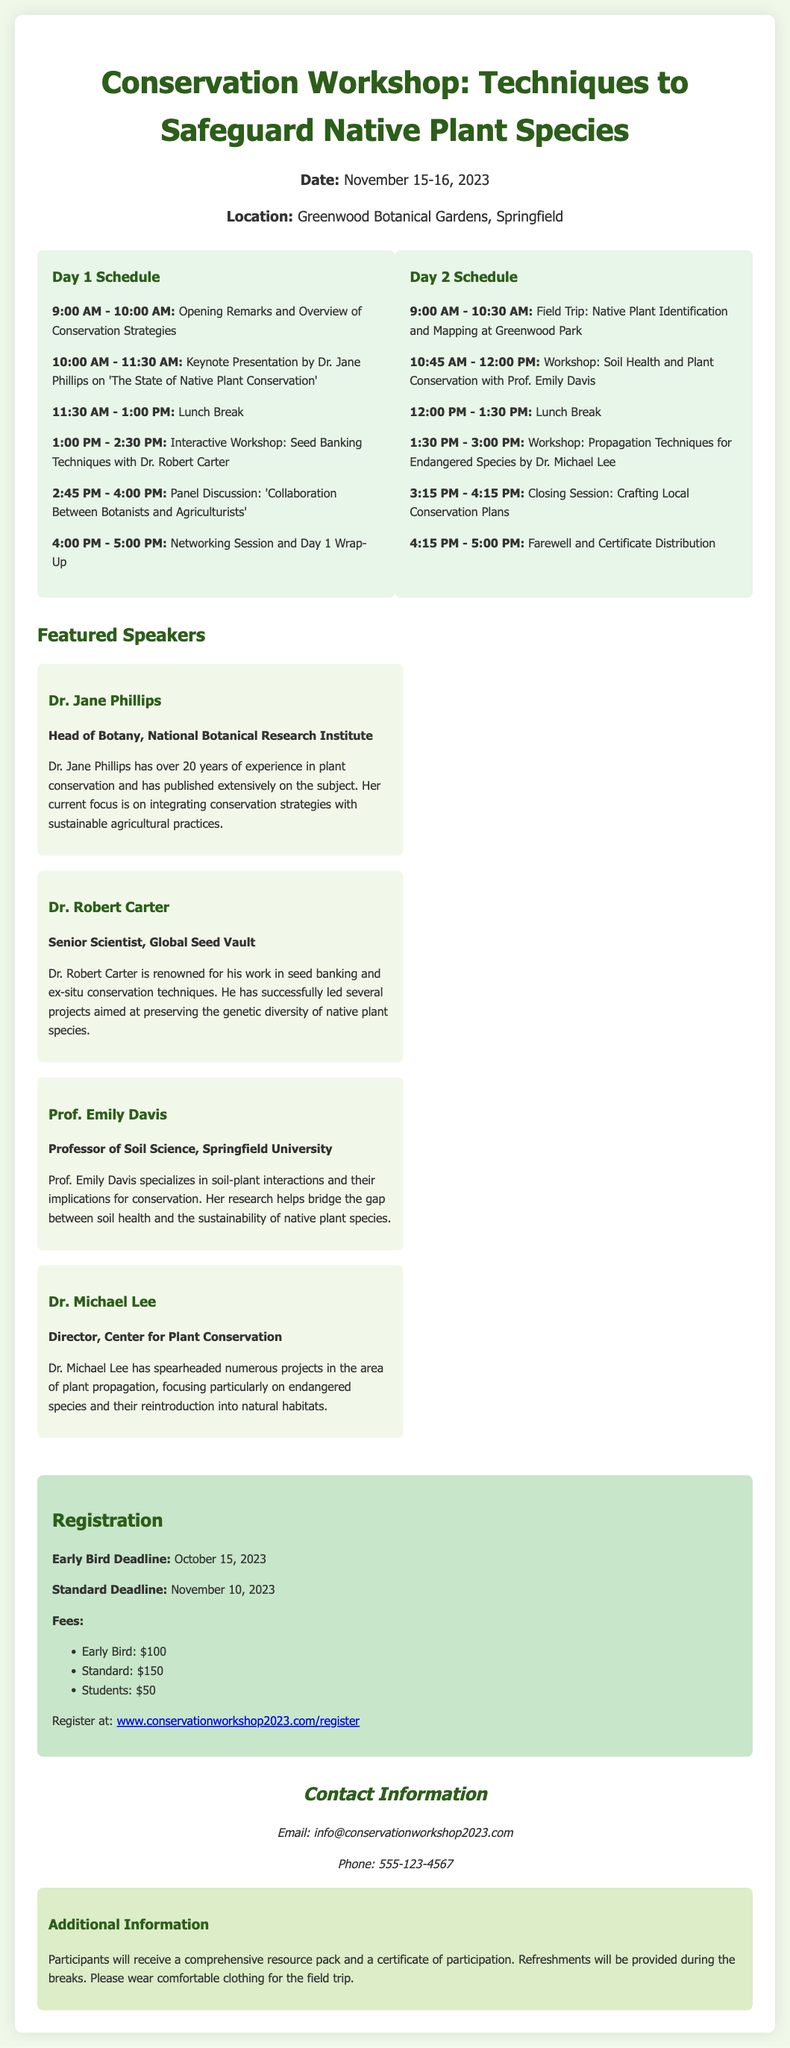What are the workshop dates? The document specifies that the workshop will take place on November 15-16, 2023.
Answer: November 15-16, 2023 Where is the workshop located? The location of the workshop is mentioned in the document as Greenwood Botanical Gardens, Springfield.
Answer: Greenwood Botanical Gardens, Springfield Who is the keynote speaker? The document identifies Dr. Jane Phillips as the keynote speaker who will present on 'The State of Native Plant Conservation'.
Answer: Dr. Jane Phillips What is the early bird registration fee? The document states that the early bird registration fee is $100.
Answer: $100 What session is scheduled right after the lunch break on Day 1? The document indicates that the session after the lunch break on Day 1 is an interactive workshop on Seed Banking Techniques with Dr. Robert Carter.
Answer: Interactive Workshop: Seed Banking Techniques with Dr. Robert Carter How many speakers are featured in the workshop? The document lists four speakers who are featured in the workshop.
Answer: Four What is provided to the participants during the workshop? The document mentions that participants will receive a comprehensive resource pack and a certificate of participation.
Answer: Comprehensive resource pack and a certificate of participation What is the standard registration deadline? The document specifies the standard registration deadline as November 10, 2023.
Answer: November 10, 2023 What type of session will take place during the field trip? The document indicates that the field trip will focus on Native Plant Identification and Mapping.
Answer: Native Plant Identification and Mapping 